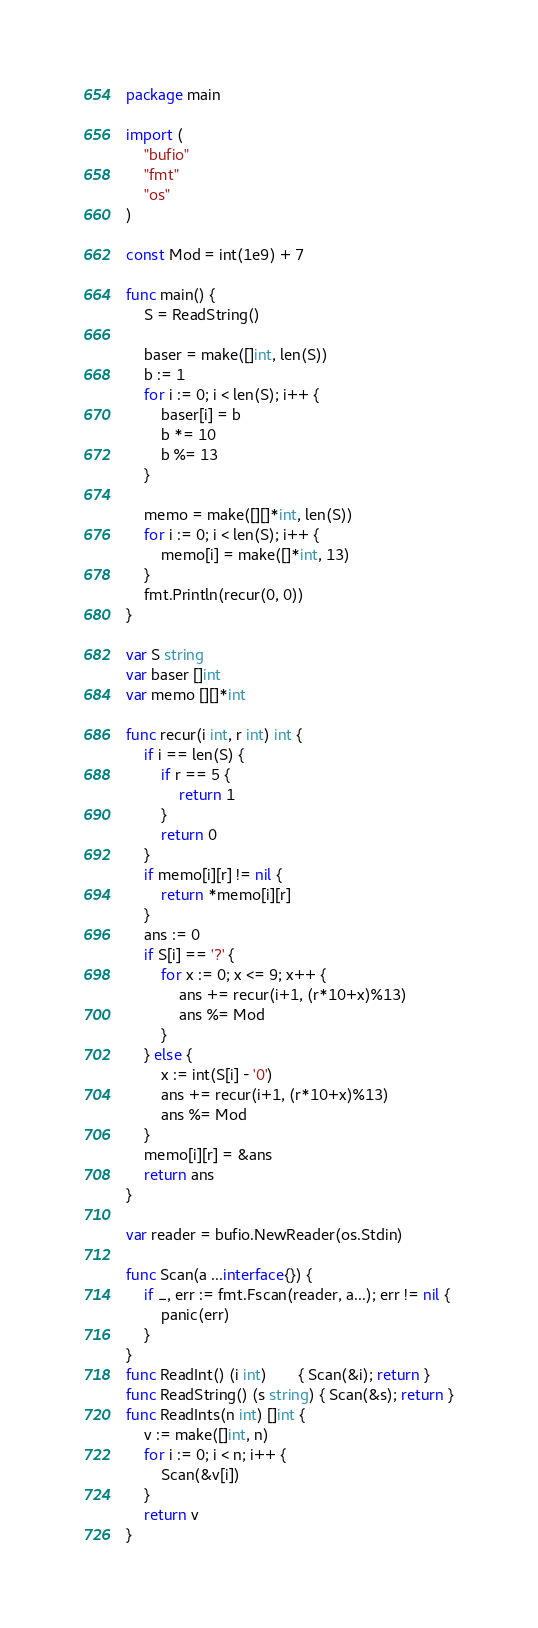<code> <loc_0><loc_0><loc_500><loc_500><_Go_>package main

import (
	"bufio"
	"fmt"
	"os"
)

const Mod = int(1e9) + 7

func main() {
	S = ReadString()

	baser = make([]int, len(S))
	b := 1
	for i := 0; i < len(S); i++ {
		baser[i] = b
		b *= 10
		b %= 13
	}

	memo = make([][]*int, len(S))
	for i := 0; i < len(S); i++ {
		memo[i] = make([]*int, 13)
	}
	fmt.Println(recur(0, 0))
}

var S string
var baser []int
var memo [][]*int

func recur(i int, r int) int {
	if i == len(S) {
		if r == 5 {
			return 1
		}
		return 0
	}
	if memo[i][r] != nil {
		return *memo[i][r]
	}
	ans := 0
	if S[i] == '?' {
		for x := 0; x <= 9; x++ {
			ans += recur(i+1, (r*10+x)%13)
			ans %= Mod
		}
	} else {
		x := int(S[i] - '0')
		ans += recur(i+1, (r*10+x)%13)
		ans %= Mod
	}
	memo[i][r] = &ans
	return ans
}

var reader = bufio.NewReader(os.Stdin)

func Scan(a ...interface{}) {
	if _, err := fmt.Fscan(reader, a...); err != nil {
		panic(err)
	}
}
func ReadInt() (i int)       { Scan(&i); return }
func ReadString() (s string) { Scan(&s); return }
func ReadInts(n int) []int {
	v := make([]int, n)
	for i := 0; i < n; i++ {
		Scan(&v[i])
	}
	return v
}
</code> 